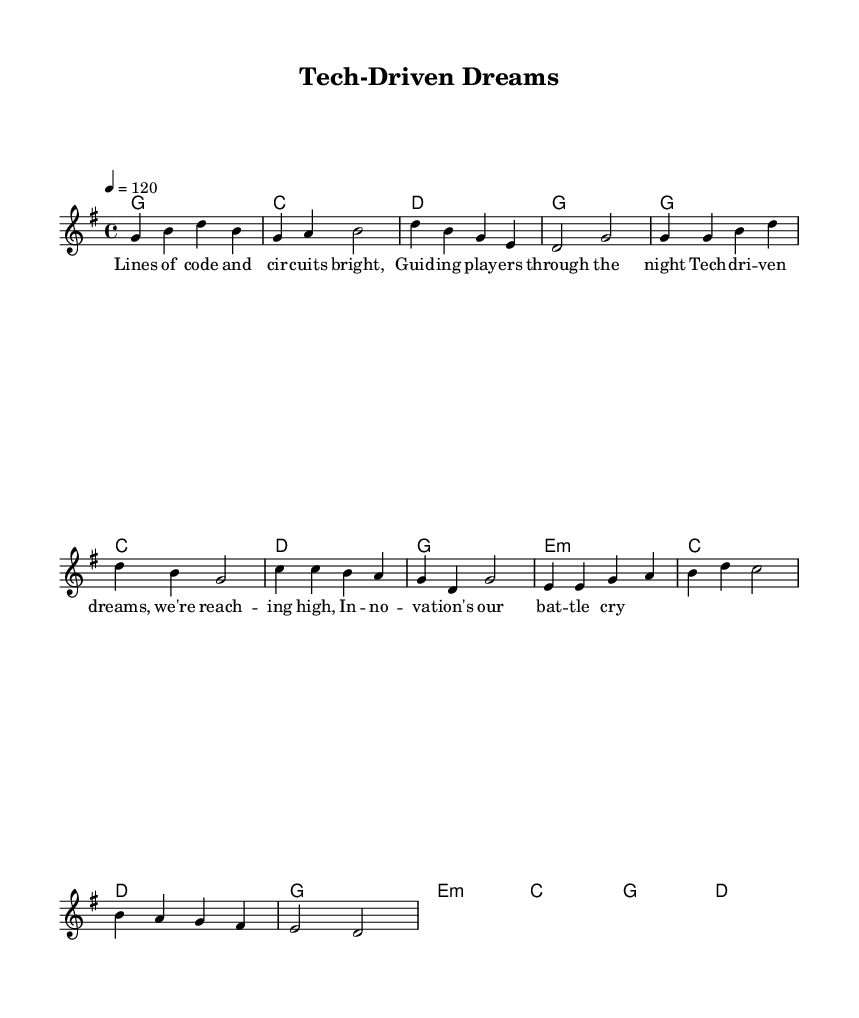What is the key signature of this music? The key signature is G major, which has one sharp (F#).
Answer: G major What is the time signature of the piece? The time signature is 4/4, which indicates four beats per measure.
Answer: 4/4 What is the tempo marking of this piece? The tempo marking is 120 beats per minute, indicated by the notation "4 = 120".
Answer: 120 How many measures are in the verse section? The verse section consists of 4 measures, indicated in the melody part.
Answer: 4 What chords are used in the chorus? The chorus uses the chords G, C, D, E minor, which can be seen in the harmonies section.
Answer: G, C, D, E minor What theme is expressed in the lyrics of the chorus? The theme of the chorus revolves around innovation and ambition, highlighted by phrases like "Tech-driven dreams" and "innovation's our battle cry".
Answer: Innovation and ambition What type of song structure is used in this piece? The song structure employs a verse-chorus format, with clear sections for both the verse and the chorus.
Answer: Verse-chorus format 